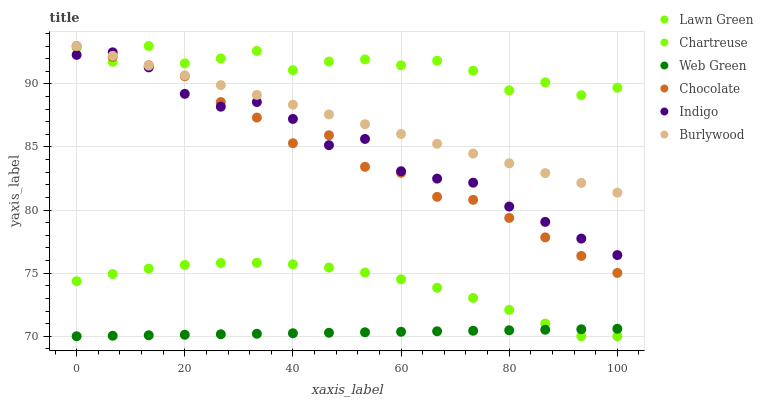Does Web Green have the minimum area under the curve?
Answer yes or no. Yes. Does Chartreuse have the maximum area under the curve?
Answer yes or no. Yes. Does Indigo have the minimum area under the curve?
Answer yes or no. No. Does Indigo have the maximum area under the curve?
Answer yes or no. No. Is Web Green the smoothest?
Answer yes or no. Yes. Is Chartreuse the roughest?
Answer yes or no. Yes. Is Indigo the smoothest?
Answer yes or no. No. Is Indigo the roughest?
Answer yes or no. No. Does Lawn Green have the lowest value?
Answer yes or no. Yes. Does Indigo have the lowest value?
Answer yes or no. No. Does Chartreuse have the highest value?
Answer yes or no. Yes. Does Indigo have the highest value?
Answer yes or no. No. Is Lawn Green less than Chartreuse?
Answer yes or no. Yes. Is Indigo greater than Web Green?
Answer yes or no. Yes. Does Chocolate intersect Chartreuse?
Answer yes or no. Yes. Is Chocolate less than Chartreuse?
Answer yes or no. No. Is Chocolate greater than Chartreuse?
Answer yes or no. No. Does Lawn Green intersect Chartreuse?
Answer yes or no. No. 